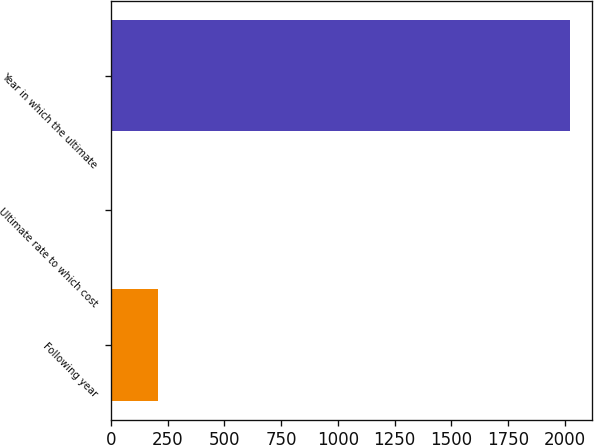<chart> <loc_0><loc_0><loc_500><loc_500><bar_chart><fcel>Following year<fcel>Ultimate rate to which cost<fcel>Year in which the ultimate<nl><fcel>206.5<fcel>5<fcel>2020<nl></chart> 